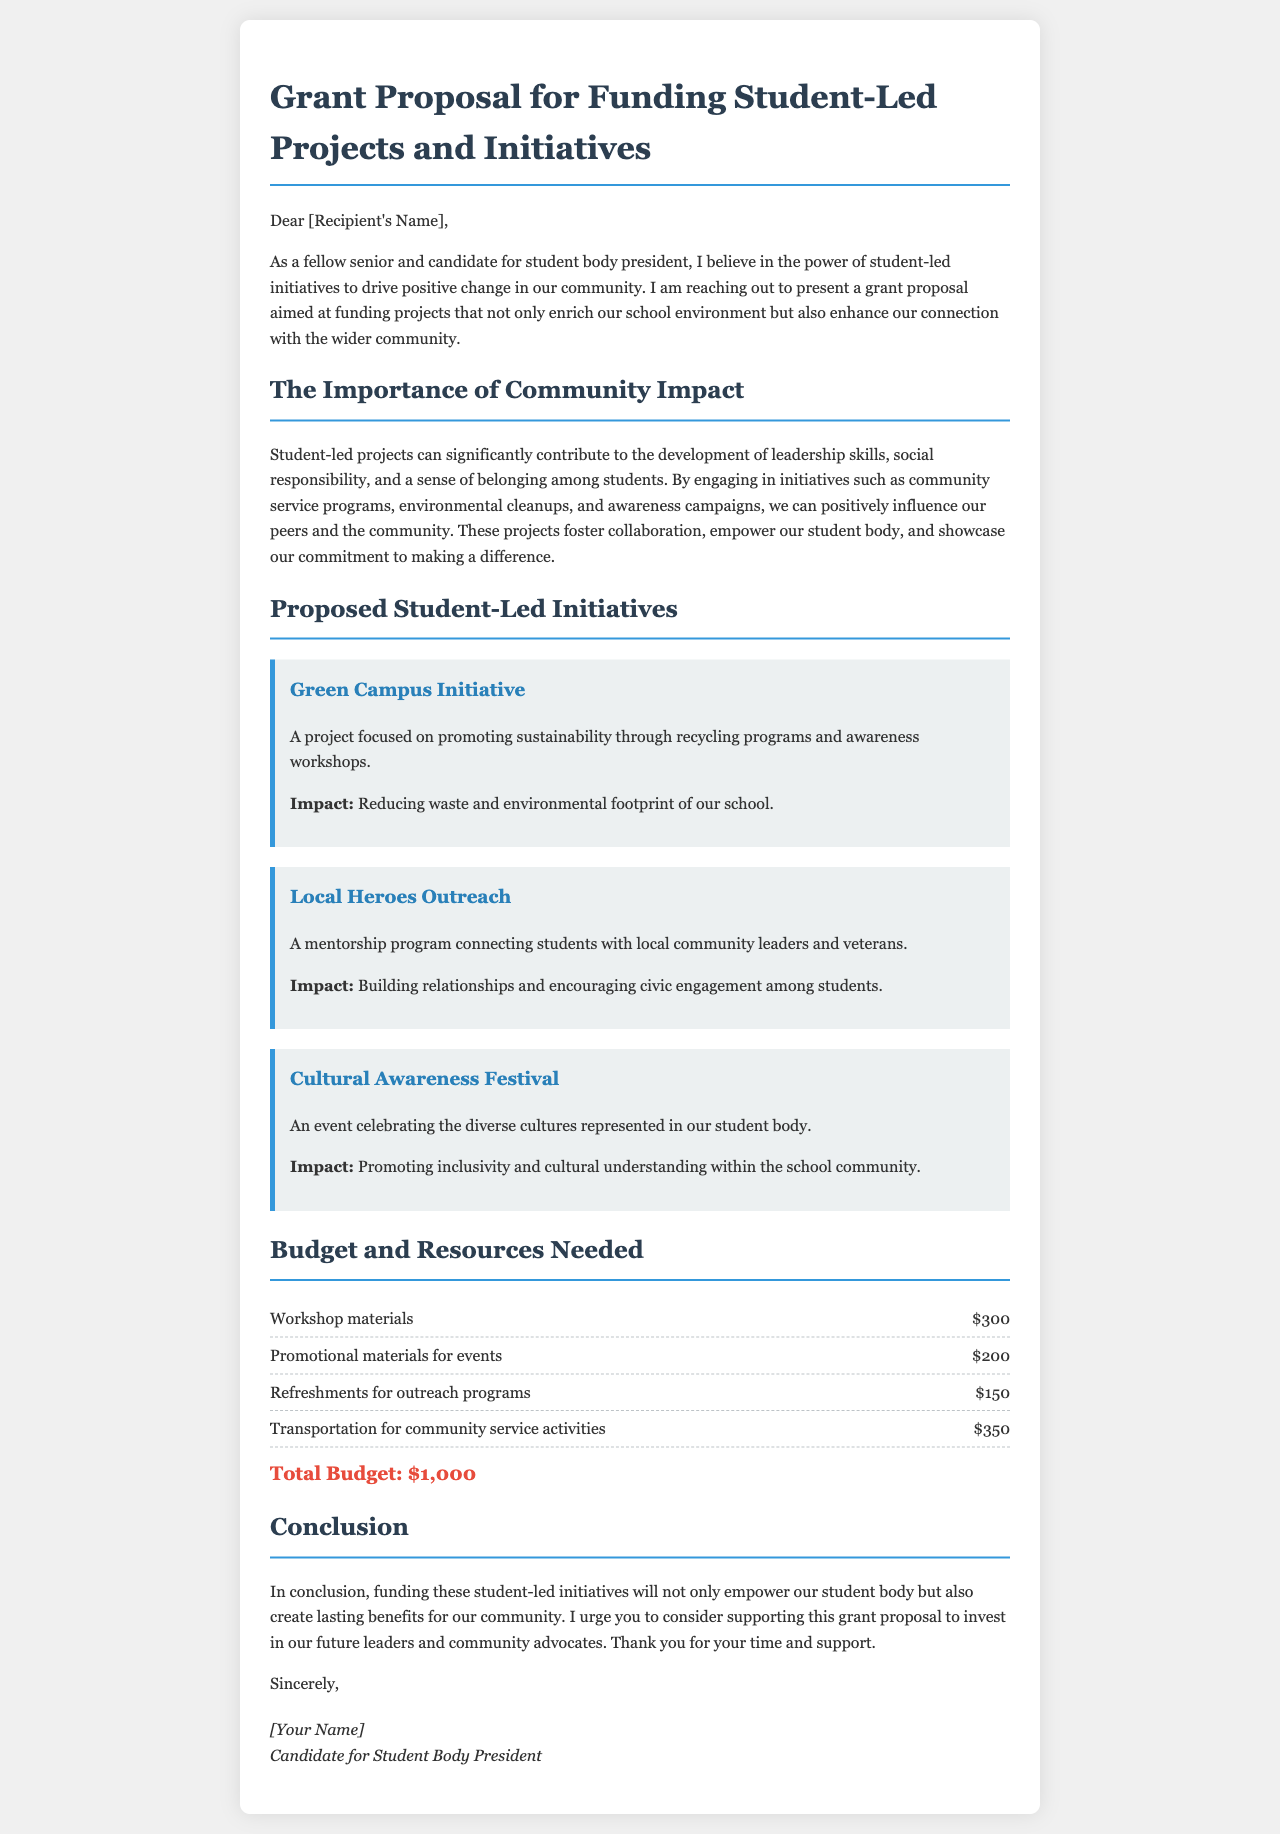What is the title of the document? The title is presented at the top of the document, indicating the main topic covered.
Answer: Grant Proposal for Funding Student-Led Projects and Initiatives Who is the author of the document? The author's name is found at the bottom of the document where the signature is located.
Answer: [Your Name] What is the total budget requested? The total budget is calculated by summing the individual items listed in the budget section.
Answer: $1,000 What project focuses on sustainability? This project is specifically designed to promote environmental awareness and action within the school.
Answer: Green Campus Initiative What type of event is the Cultural Awareness Festival? The name of the event indicates a celebration of cultural diversity among the student body.
Answer: An event celebrating diverse cultures What is one expected impact of the Local Heroes Outreach program? The impact is noted in the description, indicating the goal of the program in terms of relationships and engagement.
Answer: Building relationships What materials are needed for workshops? This information is detailed in the budget section, indicating specific items required for the initiative.
Answer: Workshop materials What is the purpose of the proposed initiatives? The text explains the overall aim of the initiatives in fostering leadership and responsibility.
Answer: To empower our student body How are the projects expected to affect the community? The document discusses the broader implications of these student-led projects on social responsibility and engagement.
Answer: Create lasting benefits for our community 